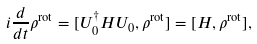<formula> <loc_0><loc_0><loc_500><loc_500>i \frac { d } { d t } \rho ^ { \text {rot} } = [ U _ { 0 } ^ { \dagger } H U _ { 0 } , \rho ^ { \text {rot} } ] = [ H , \rho ^ { \text {rot} } ] ,</formula> 